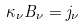<formula> <loc_0><loc_0><loc_500><loc_500>\kappa _ { \nu } B _ { \nu } = j _ { \nu }</formula> 